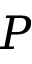Convert formula to latex. <formula><loc_0><loc_0><loc_500><loc_500>P</formula> 